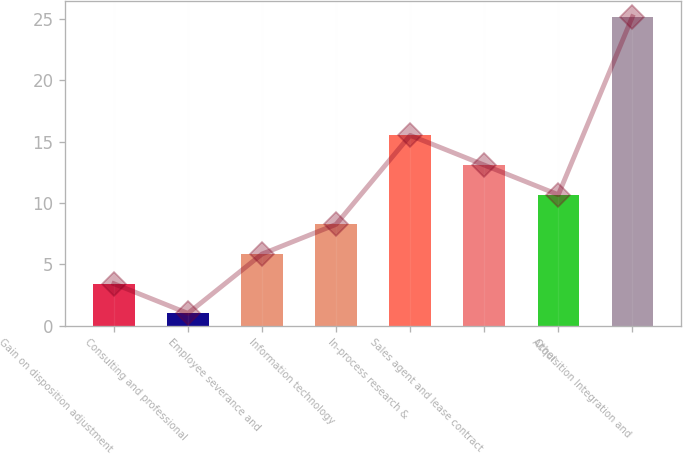Convert chart to OTSL. <chart><loc_0><loc_0><loc_500><loc_500><bar_chart><fcel>Gain on disposition adjustment<fcel>Consulting and professional<fcel>Employee severance and<fcel>Information technology<fcel>In-process research &<fcel>Sales agent and lease contract<fcel>Other<fcel>Acquisition Integration and<nl><fcel>3.42<fcel>1<fcel>5.84<fcel>8.26<fcel>15.52<fcel>13.1<fcel>10.68<fcel>25.2<nl></chart> 